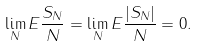Convert formula to latex. <formula><loc_0><loc_0><loc_500><loc_500>\lim _ { N } E \frac { S _ { N } } { N } = \lim _ { N } E \frac { | S _ { N } | } { N } = 0 .</formula> 